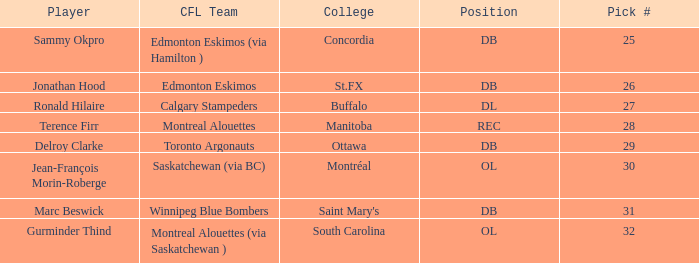Which Pick # has a College of concordia? 25.0. 